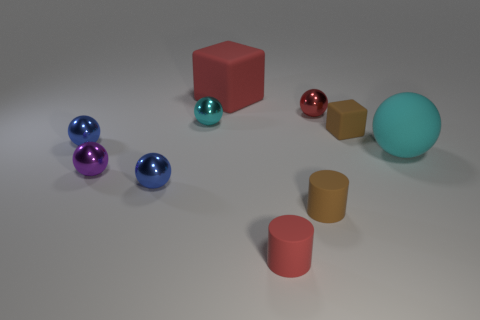Subtract all small red metallic spheres. How many spheres are left? 5 Subtract all purple balls. How many balls are left? 5 Subtract all red spheres. Subtract all yellow cylinders. How many spheres are left? 5 Subtract all blocks. How many objects are left? 8 Subtract all tiny brown matte cubes. Subtract all brown objects. How many objects are left? 7 Add 3 tiny cylinders. How many tiny cylinders are left? 5 Add 6 cyan shiny balls. How many cyan shiny balls exist? 7 Subtract 0 blue cylinders. How many objects are left? 10 